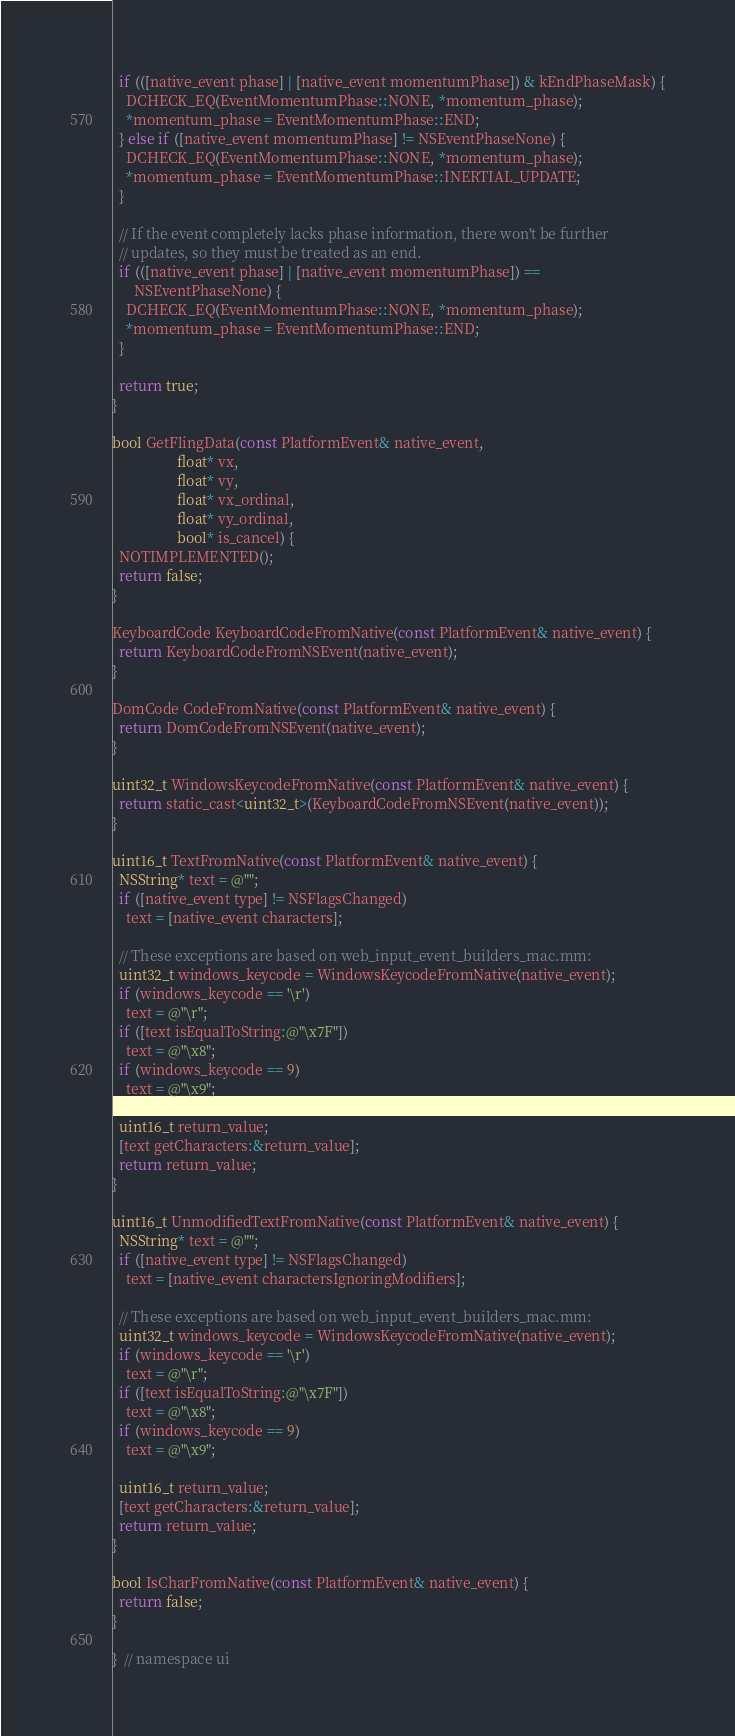<code> <loc_0><loc_0><loc_500><loc_500><_ObjectiveC_>
  if (([native_event phase] | [native_event momentumPhase]) & kEndPhaseMask) {
    DCHECK_EQ(EventMomentumPhase::NONE, *momentum_phase);
    *momentum_phase = EventMomentumPhase::END;
  } else if ([native_event momentumPhase] != NSEventPhaseNone) {
    DCHECK_EQ(EventMomentumPhase::NONE, *momentum_phase);
    *momentum_phase = EventMomentumPhase::INERTIAL_UPDATE;
  }

  // If the event completely lacks phase information, there won't be further
  // updates, so they must be treated as an end.
  if (([native_event phase] | [native_event momentumPhase]) ==
      NSEventPhaseNone) {
    DCHECK_EQ(EventMomentumPhase::NONE, *momentum_phase);
    *momentum_phase = EventMomentumPhase::END;
  }

  return true;
}

bool GetFlingData(const PlatformEvent& native_event,
                  float* vx,
                  float* vy,
                  float* vx_ordinal,
                  float* vy_ordinal,
                  bool* is_cancel) {
  NOTIMPLEMENTED();
  return false;
}

KeyboardCode KeyboardCodeFromNative(const PlatformEvent& native_event) {
  return KeyboardCodeFromNSEvent(native_event);
}

DomCode CodeFromNative(const PlatformEvent& native_event) {
  return DomCodeFromNSEvent(native_event);
}

uint32_t WindowsKeycodeFromNative(const PlatformEvent& native_event) {
  return static_cast<uint32_t>(KeyboardCodeFromNSEvent(native_event));
}

uint16_t TextFromNative(const PlatformEvent& native_event) {
  NSString* text = @"";
  if ([native_event type] != NSFlagsChanged)
    text = [native_event characters];

  // These exceptions are based on web_input_event_builders_mac.mm:
  uint32_t windows_keycode = WindowsKeycodeFromNative(native_event);
  if (windows_keycode == '\r')
    text = @"\r";
  if ([text isEqualToString:@"\x7F"])
    text = @"\x8";
  if (windows_keycode == 9)
    text = @"\x9";

  uint16_t return_value;
  [text getCharacters:&return_value];
  return return_value;
}

uint16_t UnmodifiedTextFromNative(const PlatformEvent& native_event) {
  NSString* text = @"";
  if ([native_event type] != NSFlagsChanged)
    text = [native_event charactersIgnoringModifiers];

  // These exceptions are based on web_input_event_builders_mac.mm:
  uint32_t windows_keycode = WindowsKeycodeFromNative(native_event);
  if (windows_keycode == '\r')
    text = @"\r";
  if ([text isEqualToString:@"\x7F"])
    text = @"\x8";
  if (windows_keycode == 9)
    text = @"\x9";

  uint16_t return_value;
  [text getCharacters:&return_value];
  return return_value;
}

bool IsCharFromNative(const PlatformEvent& native_event) {
  return false;
}

}  // namespace ui
</code> 